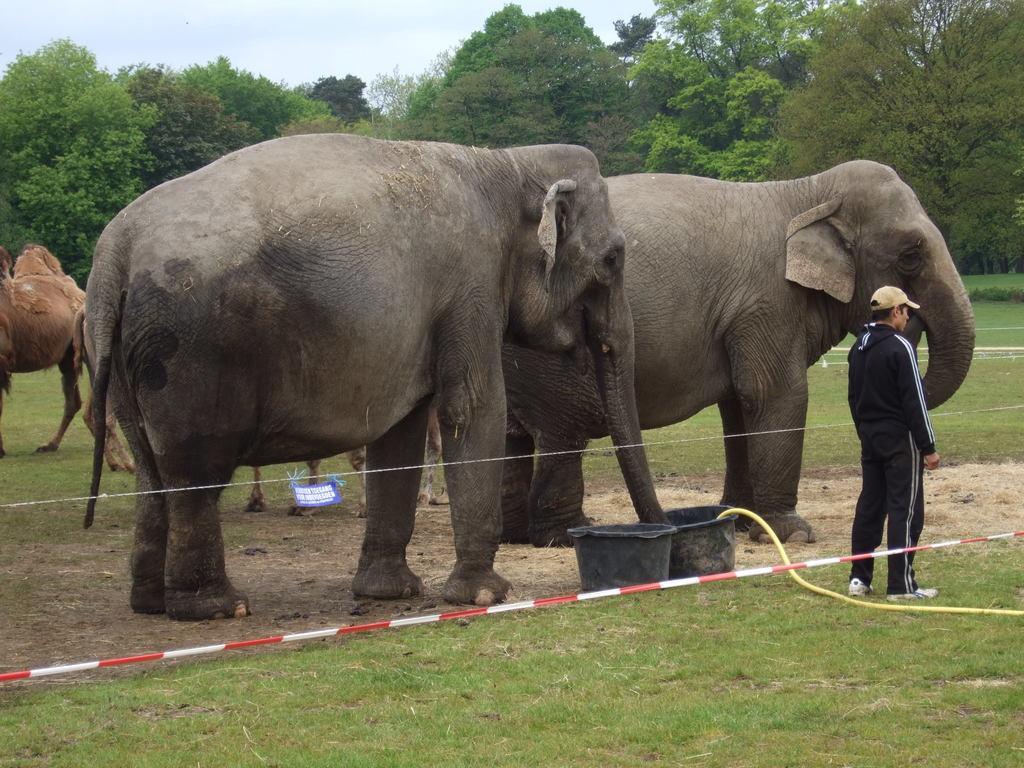Please provide a concise description of this image. In this image we can see some animals on the ground, there are some trees, grass, tubs and a pipe, in the background, we can see the sky. 